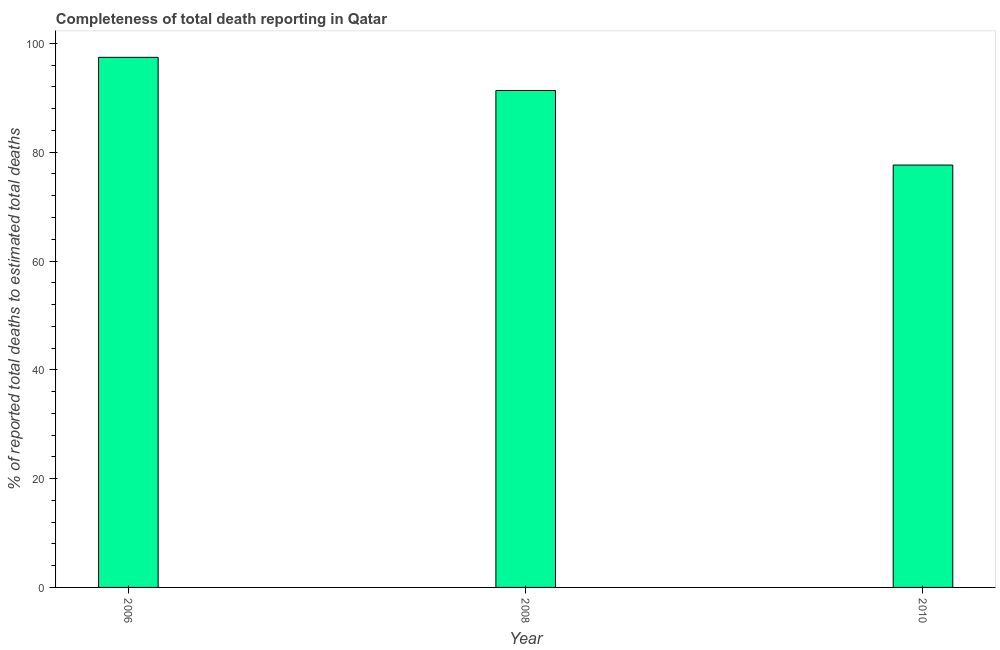What is the title of the graph?
Your answer should be very brief. Completeness of total death reporting in Qatar. What is the label or title of the X-axis?
Your response must be concise. Year. What is the label or title of the Y-axis?
Your answer should be compact. % of reported total deaths to estimated total deaths. What is the completeness of total death reports in 2008?
Offer a very short reply. 91.35. Across all years, what is the maximum completeness of total death reports?
Your answer should be compact. 97.44. Across all years, what is the minimum completeness of total death reports?
Keep it short and to the point. 77.64. What is the sum of the completeness of total death reports?
Provide a succinct answer. 266.42. What is the difference between the completeness of total death reports in 2006 and 2010?
Ensure brevity in your answer.  19.8. What is the average completeness of total death reports per year?
Make the answer very short. 88.81. What is the median completeness of total death reports?
Offer a very short reply. 91.35. In how many years, is the completeness of total death reports greater than 44 %?
Offer a very short reply. 3. Do a majority of the years between 2006 and 2010 (inclusive) have completeness of total death reports greater than 48 %?
Provide a succinct answer. Yes. What is the ratio of the completeness of total death reports in 2006 to that in 2008?
Offer a very short reply. 1.07. What is the difference between the highest and the second highest completeness of total death reports?
Ensure brevity in your answer.  6.09. What is the difference between the highest and the lowest completeness of total death reports?
Give a very brief answer. 19.8. In how many years, is the completeness of total death reports greater than the average completeness of total death reports taken over all years?
Your answer should be very brief. 2. How many bars are there?
Ensure brevity in your answer.  3. Are all the bars in the graph horizontal?
Ensure brevity in your answer.  No. How many years are there in the graph?
Ensure brevity in your answer.  3. What is the difference between two consecutive major ticks on the Y-axis?
Ensure brevity in your answer.  20. What is the % of reported total deaths to estimated total deaths in 2006?
Your response must be concise. 97.44. What is the % of reported total deaths to estimated total deaths in 2008?
Ensure brevity in your answer.  91.35. What is the % of reported total deaths to estimated total deaths of 2010?
Give a very brief answer. 77.64. What is the difference between the % of reported total deaths to estimated total deaths in 2006 and 2008?
Your answer should be compact. 6.09. What is the difference between the % of reported total deaths to estimated total deaths in 2006 and 2010?
Make the answer very short. 19.8. What is the difference between the % of reported total deaths to estimated total deaths in 2008 and 2010?
Provide a succinct answer. 13.71. What is the ratio of the % of reported total deaths to estimated total deaths in 2006 to that in 2008?
Make the answer very short. 1.07. What is the ratio of the % of reported total deaths to estimated total deaths in 2006 to that in 2010?
Your answer should be compact. 1.25. What is the ratio of the % of reported total deaths to estimated total deaths in 2008 to that in 2010?
Your answer should be compact. 1.18. 